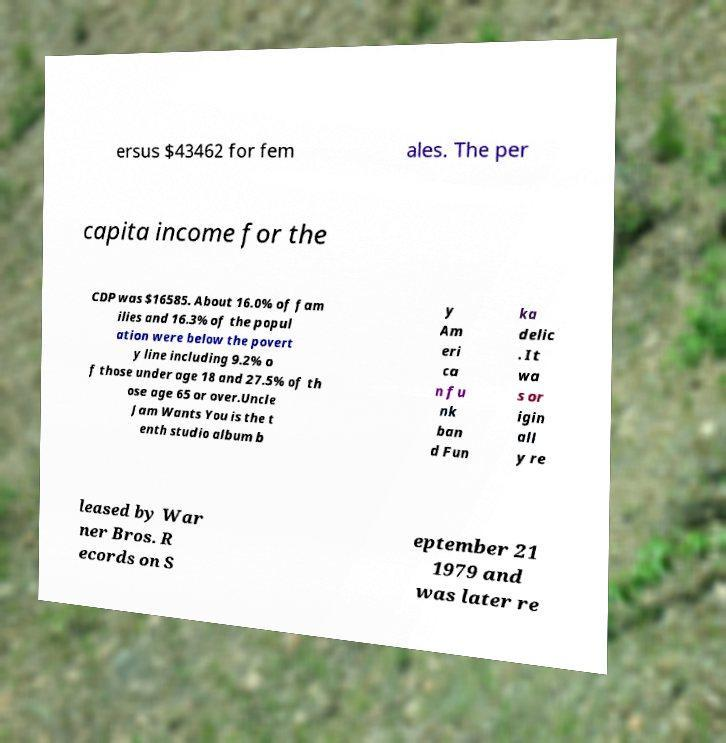There's text embedded in this image that I need extracted. Can you transcribe it verbatim? ersus $43462 for fem ales. The per capita income for the CDP was $16585. About 16.0% of fam ilies and 16.3% of the popul ation were below the povert y line including 9.2% o f those under age 18 and 27.5% of th ose age 65 or over.Uncle Jam Wants You is the t enth studio album b y Am eri ca n fu nk ban d Fun ka delic . It wa s or igin all y re leased by War ner Bros. R ecords on S eptember 21 1979 and was later re 